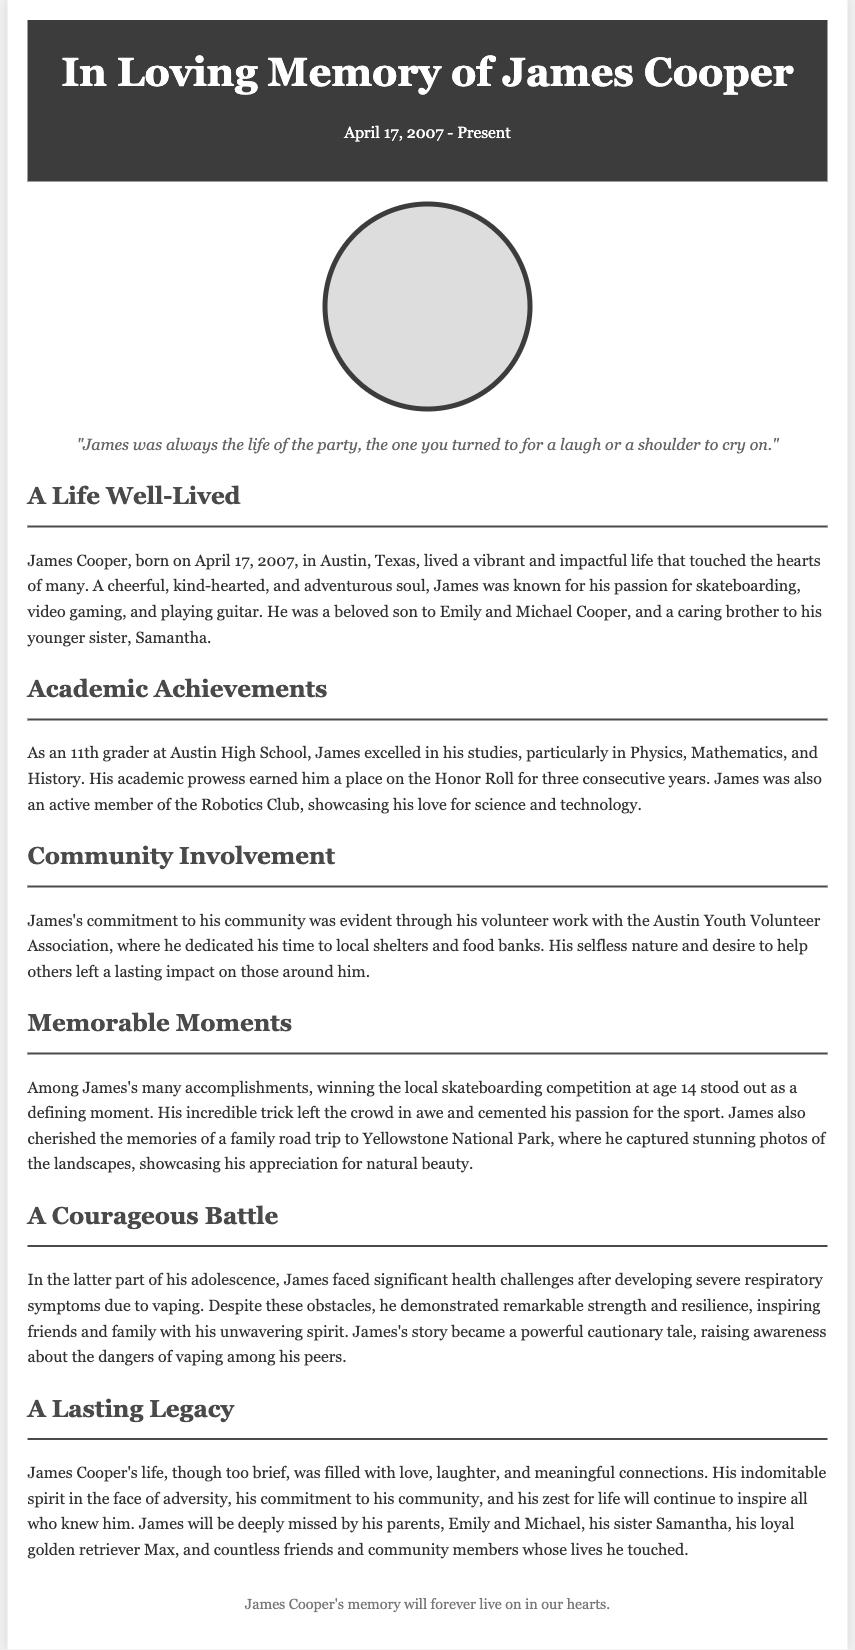What is James Cooper's birth date? James Cooper was born on April 17, 2007, as stated in the document.
Answer: April 17, 2007 Who are James's parents? The document names Emily and Michael Cooper as James's parents.
Answer: Emily and Michael Cooper What was James’s favorite sport? The document mentions James's passion for skateboarding, indicating it was his favorite sport.
Answer: Skateboarding How many years was James on the Honor Roll? The text states that James earned a place on the Honor Roll for three consecutive years.
Answer: Three years What was a significant challenge James faced? The document notes James faced significant health challenges due to severe respiratory symptoms from vaping.
Answer: Severe respiratory symptoms What community organization did James volunteer with? The text mentions James volunteering with the Austin Youth Volunteer Association.
Answer: Austin Youth Volunteer Association What memorable family trip is mentioned? The document references a family road trip to Yellowstone National Park as a memorable moment for James.
Answer: Yellowstone National Park What is a key aspect of James's legacy? The document emphasizes James's indomitable spirit and impact on his community as key aspects of his legacy.
Answer: Indomitable spirit and impact on his community 